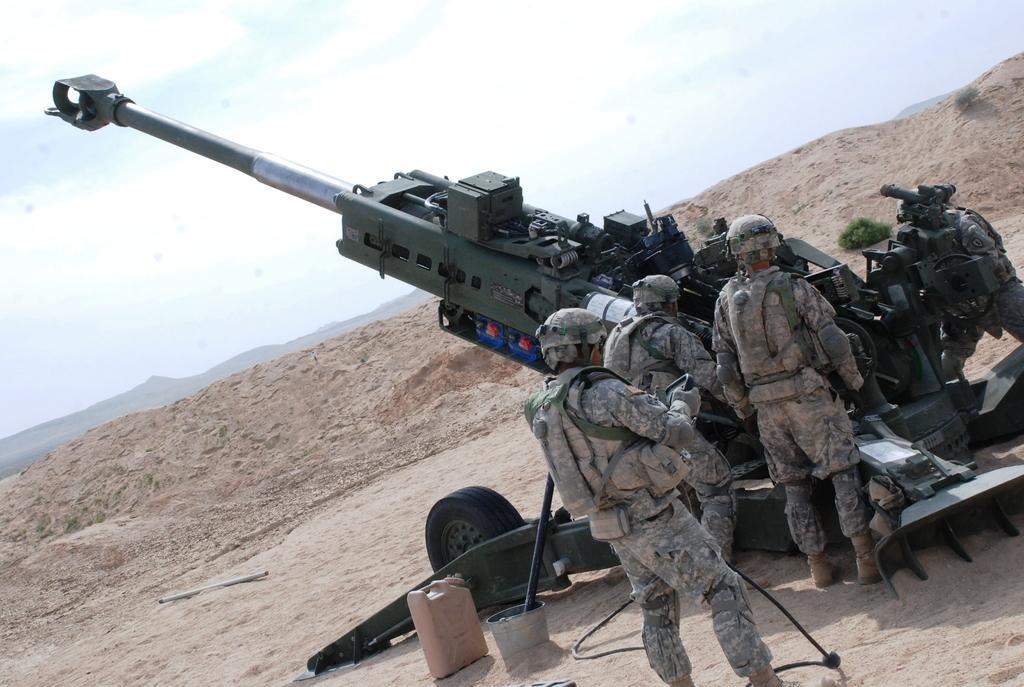In one or two sentences, can you explain what this image depicts? In this image we can see some people around the missile on the rock and around there are some other mountains. 